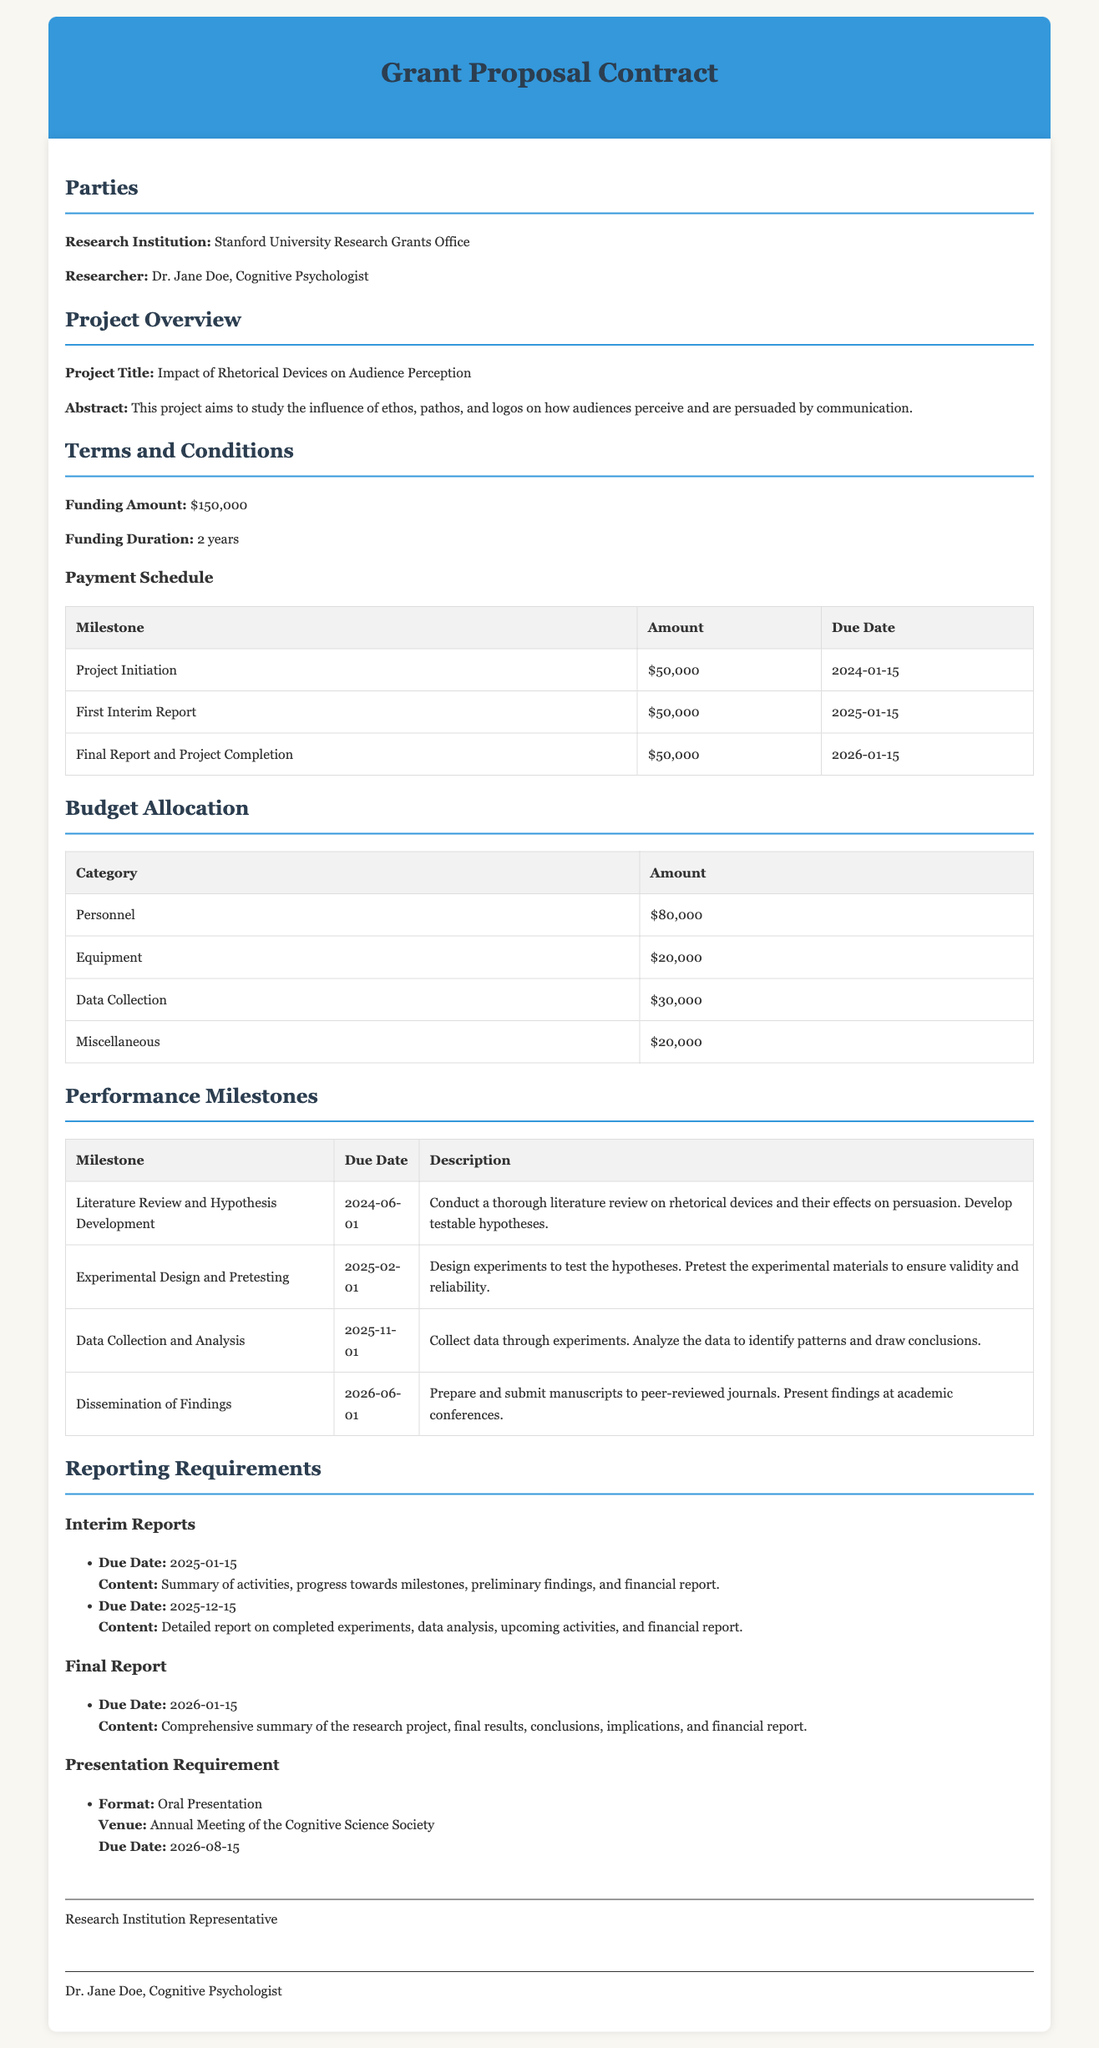What is the funding amount? The funding amount is explicitly stated in the terms and conditions section of the document.
Answer: $150,000 Who is the researcher? The researcher is identified in the parties section of the document.
Answer: Dr. Jane Doe, Cognitive Psychologist What is the project title? The project title is stated in the project overview section.
Answer: Impact of Rhetorical Devices on Audience Perception When is the final report due? The due date for the final report is mentioned in the reporting requirements section.
Answer: 2026-01-15 How many milestones are listed? The number of milestones can be counted in the performance milestones section of the document.
Answer: 4 What is the budget allocation for personnel? The amount allocated for personnel is specified in the budget allocation section.
Answer: $80,000 What is the due date for the first interim report? The due date is provided in the reporting requirements section under interim reports.
Answer: 2025-01-15 What is the venue for the presentation requirement? The venue for the presentation is indicated in the reporting requirements section.
Answer: Annual Meeting of the Cognitive Science Society What is the duration of funding? The duration of the funding is clearly stated in the terms and conditions section.
Answer: 2 years 